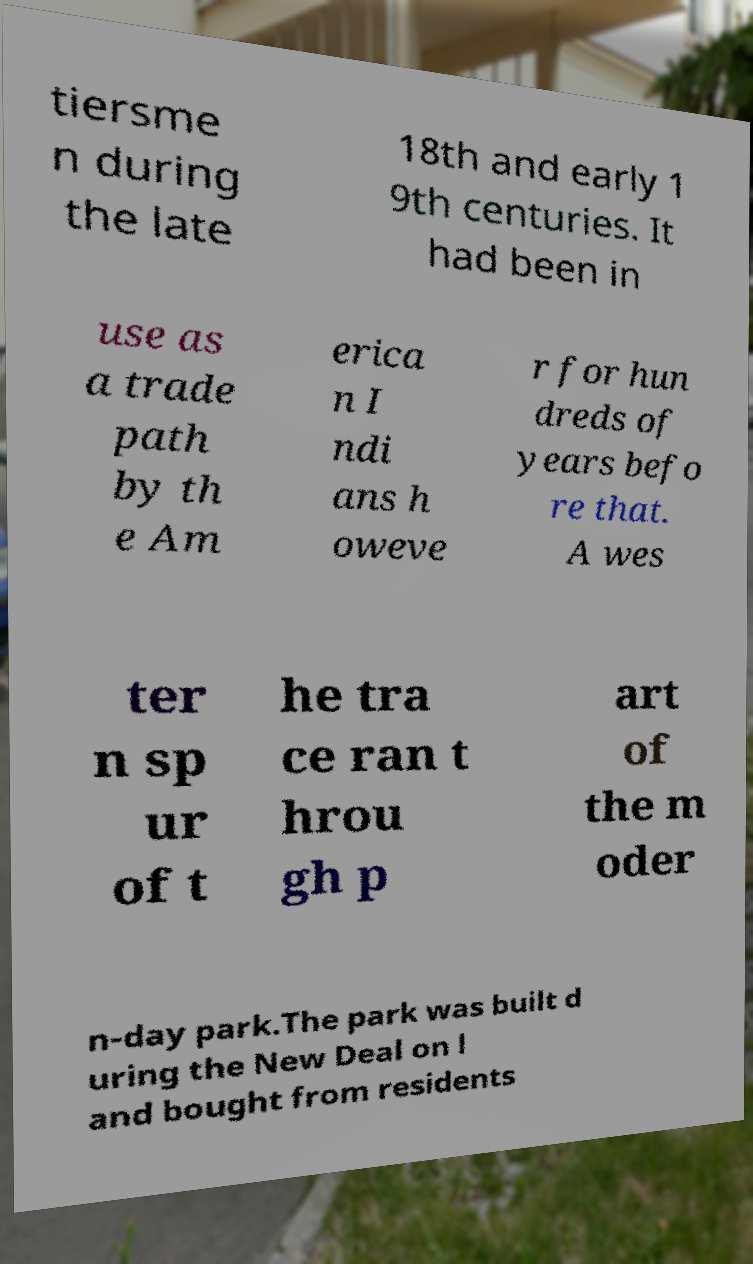Can you read and provide the text displayed in the image?This photo seems to have some interesting text. Can you extract and type it out for me? tiersme n during the late 18th and early 1 9th centuries. It had been in use as a trade path by th e Am erica n I ndi ans h oweve r for hun dreds of years befo re that. A wes ter n sp ur of t he tra ce ran t hrou gh p art of the m oder n-day park.The park was built d uring the New Deal on l and bought from residents 